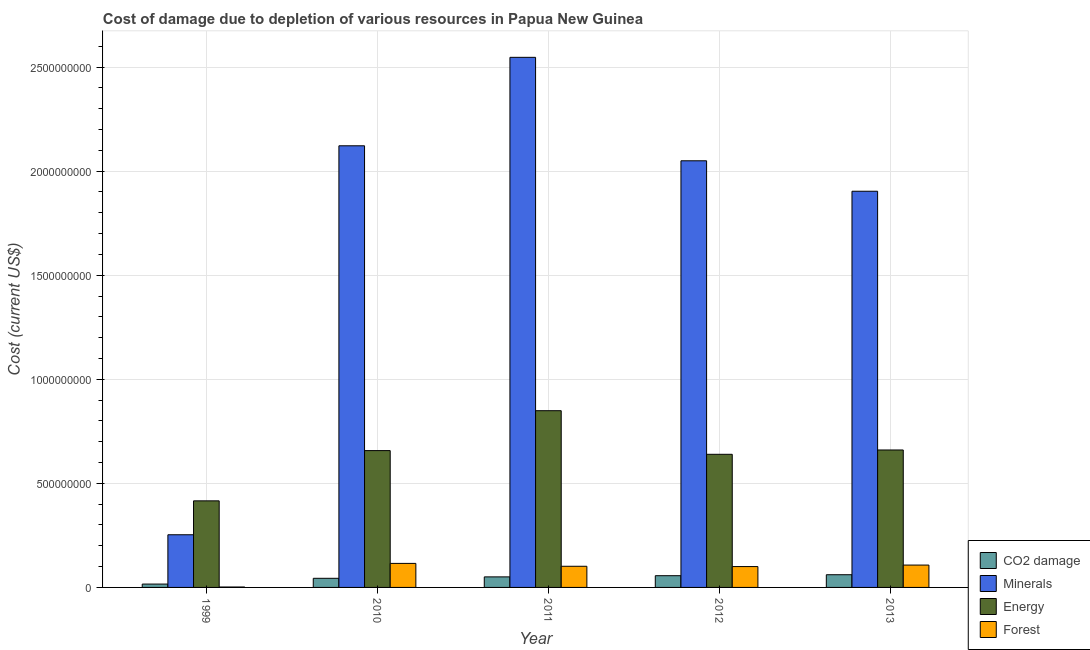How many different coloured bars are there?
Your answer should be very brief. 4. How many bars are there on the 1st tick from the left?
Provide a short and direct response. 4. In how many cases, is the number of bars for a given year not equal to the number of legend labels?
Provide a succinct answer. 0. What is the cost of damage due to depletion of energy in 2013?
Your response must be concise. 6.60e+08. Across all years, what is the maximum cost of damage due to depletion of energy?
Provide a succinct answer. 8.49e+08. Across all years, what is the minimum cost of damage due to depletion of forests?
Keep it short and to the point. 2.04e+06. In which year was the cost of damage due to depletion of minerals maximum?
Ensure brevity in your answer.  2011. What is the total cost of damage due to depletion of coal in the graph?
Provide a succinct answer. 2.28e+08. What is the difference between the cost of damage due to depletion of forests in 2010 and that in 2013?
Offer a very short reply. 8.03e+06. What is the difference between the cost of damage due to depletion of energy in 2010 and the cost of damage due to depletion of minerals in 1999?
Offer a terse response. 2.41e+08. What is the average cost of damage due to depletion of coal per year?
Make the answer very short. 4.56e+07. In how many years, is the cost of damage due to depletion of minerals greater than 2400000000 US$?
Your answer should be compact. 1. What is the ratio of the cost of damage due to depletion of minerals in 2010 to that in 2012?
Ensure brevity in your answer.  1.04. Is the difference between the cost of damage due to depletion of minerals in 1999 and 2010 greater than the difference between the cost of damage due to depletion of energy in 1999 and 2010?
Your answer should be compact. No. What is the difference between the highest and the second highest cost of damage due to depletion of minerals?
Provide a short and direct response. 4.25e+08. What is the difference between the highest and the lowest cost of damage due to depletion of forests?
Provide a short and direct response. 1.13e+08. In how many years, is the cost of damage due to depletion of minerals greater than the average cost of damage due to depletion of minerals taken over all years?
Your answer should be very brief. 4. Is it the case that in every year, the sum of the cost of damage due to depletion of energy and cost of damage due to depletion of coal is greater than the sum of cost of damage due to depletion of minerals and cost of damage due to depletion of forests?
Provide a succinct answer. No. What does the 4th bar from the left in 2011 represents?
Your answer should be compact. Forest. What does the 2nd bar from the right in 1999 represents?
Your answer should be very brief. Energy. Is it the case that in every year, the sum of the cost of damage due to depletion of coal and cost of damage due to depletion of minerals is greater than the cost of damage due to depletion of energy?
Keep it short and to the point. No. How many bars are there?
Your answer should be compact. 20. Are all the bars in the graph horizontal?
Your answer should be compact. No. How many years are there in the graph?
Your answer should be very brief. 5. Does the graph contain any zero values?
Ensure brevity in your answer.  No. Where does the legend appear in the graph?
Your response must be concise. Bottom right. What is the title of the graph?
Offer a terse response. Cost of damage due to depletion of various resources in Papua New Guinea . What is the label or title of the X-axis?
Provide a short and direct response. Year. What is the label or title of the Y-axis?
Make the answer very short. Cost (current US$). What is the Cost (current US$) in CO2 damage in 1999?
Ensure brevity in your answer.  1.61e+07. What is the Cost (current US$) of Minerals in 1999?
Make the answer very short. 2.53e+08. What is the Cost (current US$) in Energy in 1999?
Your answer should be very brief. 4.16e+08. What is the Cost (current US$) in Forest in 1999?
Keep it short and to the point. 2.04e+06. What is the Cost (current US$) of CO2 damage in 2010?
Your answer should be very brief. 4.38e+07. What is the Cost (current US$) in Minerals in 2010?
Make the answer very short. 2.12e+09. What is the Cost (current US$) in Energy in 2010?
Keep it short and to the point. 6.57e+08. What is the Cost (current US$) of Forest in 2010?
Provide a succinct answer. 1.15e+08. What is the Cost (current US$) of CO2 damage in 2011?
Offer a very short reply. 5.07e+07. What is the Cost (current US$) in Minerals in 2011?
Offer a terse response. 2.55e+09. What is the Cost (current US$) of Energy in 2011?
Keep it short and to the point. 8.49e+08. What is the Cost (current US$) of Forest in 2011?
Offer a very short reply. 1.02e+08. What is the Cost (current US$) in CO2 damage in 2012?
Keep it short and to the point. 5.64e+07. What is the Cost (current US$) of Minerals in 2012?
Keep it short and to the point. 2.05e+09. What is the Cost (current US$) of Energy in 2012?
Offer a very short reply. 6.40e+08. What is the Cost (current US$) of Forest in 2012?
Provide a short and direct response. 1.00e+08. What is the Cost (current US$) in CO2 damage in 2013?
Offer a very short reply. 6.10e+07. What is the Cost (current US$) of Minerals in 2013?
Offer a very short reply. 1.90e+09. What is the Cost (current US$) in Energy in 2013?
Your answer should be compact. 6.60e+08. What is the Cost (current US$) in Forest in 2013?
Keep it short and to the point. 1.07e+08. Across all years, what is the maximum Cost (current US$) of CO2 damage?
Give a very brief answer. 6.10e+07. Across all years, what is the maximum Cost (current US$) of Minerals?
Your answer should be very brief. 2.55e+09. Across all years, what is the maximum Cost (current US$) in Energy?
Keep it short and to the point. 8.49e+08. Across all years, what is the maximum Cost (current US$) of Forest?
Your response must be concise. 1.15e+08. Across all years, what is the minimum Cost (current US$) in CO2 damage?
Make the answer very short. 1.61e+07. Across all years, what is the minimum Cost (current US$) of Minerals?
Your answer should be compact. 2.53e+08. Across all years, what is the minimum Cost (current US$) in Energy?
Offer a very short reply. 4.16e+08. Across all years, what is the minimum Cost (current US$) in Forest?
Keep it short and to the point. 2.04e+06. What is the total Cost (current US$) in CO2 damage in the graph?
Your answer should be compact. 2.28e+08. What is the total Cost (current US$) in Minerals in the graph?
Give a very brief answer. 8.88e+09. What is the total Cost (current US$) in Energy in the graph?
Provide a succinct answer. 3.22e+09. What is the total Cost (current US$) in Forest in the graph?
Make the answer very short. 4.27e+08. What is the difference between the Cost (current US$) in CO2 damage in 1999 and that in 2010?
Make the answer very short. -2.77e+07. What is the difference between the Cost (current US$) of Minerals in 1999 and that in 2010?
Keep it short and to the point. -1.87e+09. What is the difference between the Cost (current US$) in Energy in 1999 and that in 2010?
Keep it short and to the point. -2.41e+08. What is the difference between the Cost (current US$) in Forest in 1999 and that in 2010?
Ensure brevity in your answer.  -1.13e+08. What is the difference between the Cost (current US$) in CO2 damage in 1999 and that in 2011?
Provide a short and direct response. -3.46e+07. What is the difference between the Cost (current US$) of Minerals in 1999 and that in 2011?
Your answer should be very brief. -2.29e+09. What is the difference between the Cost (current US$) of Energy in 1999 and that in 2011?
Give a very brief answer. -4.33e+08. What is the difference between the Cost (current US$) of Forest in 1999 and that in 2011?
Give a very brief answer. -9.96e+07. What is the difference between the Cost (current US$) in CO2 damage in 1999 and that in 2012?
Your response must be concise. -4.03e+07. What is the difference between the Cost (current US$) of Minerals in 1999 and that in 2012?
Make the answer very short. -1.80e+09. What is the difference between the Cost (current US$) in Energy in 1999 and that in 2012?
Ensure brevity in your answer.  -2.24e+08. What is the difference between the Cost (current US$) in Forest in 1999 and that in 2012?
Provide a short and direct response. -9.82e+07. What is the difference between the Cost (current US$) of CO2 damage in 1999 and that in 2013?
Keep it short and to the point. -4.49e+07. What is the difference between the Cost (current US$) of Minerals in 1999 and that in 2013?
Make the answer very short. -1.65e+09. What is the difference between the Cost (current US$) in Energy in 1999 and that in 2013?
Offer a very short reply. -2.44e+08. What is the difference between the Cost (current US$) of Forest in 1999 and that in 2013?
Offer a terse response. -1.05e+08. What is the difference between the Cost (current US$) of CO2 damage in 2010 and that in 2011?
Your response must be concise. -6.85e+06. What is the difference between the Cost (current US$) of Minerals in 2010 and that in 2011?
Keep it short and to the point. -4.25e+08. What is the difference between the Cost (current US$) in Energy in 2010 and that in 2011?
Ensure brevity in your answer.  -1.92e+08. What is the difference between the Cost (current US$) of Forest in 2010 and that in 2011?
Ensure brevity in your answer.  1.38e+07. What is the difference between the Cost (current US$) of CO2 damage in 2010 and that in 2012?
Offer a very short reply. -1.25e+07. What is the difference between the Cost (current US$) of Minerals in 2010 and that in 2012?
Offer a terse response. 7.20e+07. What is the difference between the Cost (current US$) of Energy in 2010 and that in 2012?
Ensure brevity in your answer.  1.78e+07. What is the difference between the Cost (current US$) in Forest in 2010 and that in 2012?
Offer a terse response. 1.52e+07. What is the difference between the Cost (current US$) of CO2 damage in 2010 and that in 2013?
Ensure brevity in your answer.  -1.72e+07. What is the difference between the Cost (current US$) of Minerals in 2010 and that in 2013?
Your answer should be compact. 2.18e+08. What is the difference between the Cost (current US$) in Energy in 2010 and that in 2013?
Make the answer very short. -2.94e+06. What is the difference between the Cost (current US$) in Forest in 2010 and that in 2013?
Provide a succinct answer. 8.03e+06. What is the difference between the Cost (current US$) of CO2 damage in 2011 and that in 2012?
Your response must be concise. -5.67e+06. What is the difference between the Cost (current US$) in Minerals in 2011 and that in 2012?
Give a very brief answer. 4.97e+08. What is the difference between the Cost (current US$) of Energy in 2011 and that in 2012?
Offer a terse response. 2.10e+08. What is the difference between the Cost (current US$) of Forest in 2011 and that in 2012?
Your answer should be very brief. 1.37e+06. What is the difference between the Cost (current US$) in CO2 damage in 2011 and that in 2013?
Provide a short and direct response. -1.03e+07. What is the difference between the Cost (current US$) in Minerals in 2011 and that in 2013?
Make the answer very short. 6.43e+08. What is the difference between the Cost (current US$) in Energy in 2011 and that in 2013?
Your response must be concise. 1.89e+08. What is the difference between the Cost (current US$) of Forest in 2011 and that in 2013?
Provide a short and direct response. -5.81e+06. What is the difference between the Cost (current US$) in CO2 damage in 2012 and that in 2013?
Your answer should be very brief. -4.64e+06. What is the difference between the Cost (current US$) in Minerals in 2012 and that in 2013?
Your response must be concise. 1.46e+08. What is the difference between the Cost (current US$) in Energy in 2012 and that in 2013?
Provide a short and direct response. -2.08e+07. What is the difference between the Cost (current US$) in Forest in 2012 and that in 2013?
Your answer should be compact. -7.18e+06. What is the difference between the Cost (current US$) of CO2 damage in 1999 and the Cost (current US$) of Minerals in 2010?
Give a very brief answer. -2.11e+09. What is the difference between the Cost (current US$) in CO2 damage in 1999 and the Cost (current US$) in Energy in 2010?
Offer a very short reply. -6.41e+08. What is the difference between the Cost (current US$) of CO2 damage in 1999 and the Cost (current US$) of Forest in 2010?
Offer a very short reply. -9.93e+07. What is the difference between the Cost (current US$) in Minerals in 1999 and the Cost (current US$) in Energy in 2010?
Your response must be concise. -4.04e+08. What is the difference between the Cost (current US$) in Minerals in 1999 and the Cost (current US$) in Forest in 2010?
Offer a terse response. 1.38e+08. What is the difference between the Cost (current US$) in Energy in 1999 and the Cost (current US$) in Forest in 2010?
Your response must be concise. 3.01e+08. What is the difference between the Cost (current US$) in CO2 damage in 1999 and the Cost (current US$) in Minerals in 2011?
Give a very brief answer. -2.53e+09. What is the difference between the Cost (current US$) of CO2 damage in 1999 and the Cost (current US$) of Energy in 2011?
Give a very brief answer. -8.33e+08. What is the difference between the Cost (current US$) in CO2 damage in 1999 and the Cost (current US$) in Forest in 2011?
Your answer should be very brief. -8.55e+07. What is the difference between the Cost (current US$) in Minerals in 1999 and the Cost (current US$) in Energy in 2011?
Provide a short and direct response. -5.96e+08. What is the difference between the Cost (current US$) in Minerals in 1999 and the Cost (current US$) in Forest in 2011?
Your answer should be very brief. 1.51e+08. What is the difference between the Cost (current US$) of Energy in 1999 and the Cost (current US$) of Forest in 2011?
Your response must be concise. 3.14e+08. What is the difference between the Cost (current US$) of CO2 damage in 1999 and the Cost (current US$) of Minerals in 2012?
Make the answer very short. -2.03e+09. What is the difference between the Cost (current US$) of CO2 damage in 1999 and the Cost (current US$) of Energy in 2012?
Offer a very short reply. -6.24e+08. What is the difference between the Cost (current US$) in CO2 damage in 1999 and the Cost (current US$) in Forest in 2012?
Offer a terse response. -8.41e+07. What is the difference between the Cost (current US$) of Minerals in 1999 and the Cost (current US$) of Energy in 2012?
Your answer should be very brief. -3.87e+08. What is the difference between the Cost (current US$) of Minerals in 1999 and the Cost (current US$) of Forest in 2012?
Your answer should be compact. 1.53e+08. What is the difference between the Cost (current US$) in Energy in 1999 and the Cost (current US$) in Forest in 2012?
Make the answer very short. 3.16e+08. What is the difference between the Cost (current US$) of CO2 damage in 1999 and the Cost (current US$) of Minerals in 2013?
Give a very brief answer. -1.89e+09. What is the difference between the Cost (current US$) in CO2 damage in 1999 and the Cost (current US$) in Energy in 2013?
Ensure brevity in your answer.  -6.44e+08. What is the difference between the Cost (current US$) of CO2 damage in 1999 and the Cost (current US$) of Forest in 2013?
Provide a succinct answer. -9.13e+07. What is the difference between the Cost (current US$) in Minerals in 1999 and the Cost (current US$) in Energy in 2013?
Your answer should be compact. -4.07e+08. What is the difference between the Cost (current US$) of Minerals in 1999 and the Cost (current US$) of Forest in 2013?
Keep it short and to the point. 1.46e+08. What is the difference between the Cost (current US$) of Energy in 1999 and the Cost (current US$) of Forest in 2013?
Keep it short and to the point. 3.09e+08. What is the difference between the Cost (current US$) in CO2 damage in 2010 and the Cost (current US$) in Minerals in 2011?
Your response must be concise. -2.50e+09. What is the difference between the Cost (current US$) in CO2 damage in 2010 and the Cost (current US$) in Energy in 2011?
Offer a terse response. -8.05e+08. What is the difference between the Cost (current US$) in CO2 damage in 2010 and the Cost (current US$) in Forest in 2011?
Your answer should be compact. -5.78e+07. What is the difference between the Cost (current US$) of Minerals in 2010 and the Cost (current US$) of Energy in 2011?
Keep it short and to the point. 1.27e+09. What is the difference between the Cost (current US$) of Minerals in 2010 and the Cost (current US$) of Forest in 2011?
Make the answer very short. 2.02e+09. What is the difference between the Cost (current US$) in Energy in 2010 and the Cost (current US$) in Forest in 2011?
Provide a short and direct response. 5.56e+08. What is the difference between the Cost (current US$) in CO2 damage in 2010 and the Cost (current US$) in Minerals in 2012?
Keep it short and to the point. -2.01e+09. What is the difference between the Cost (current US$) in CO2 damage in 2010 and the Cost (current US$) in Energy in 2012?
Make the answer very short. -5.96e+08. What is the difference between the Cost (current US$) in CO2 damage in 2010 and the Cost (current US$) in Forest in 2012?
Offer a very short reply. -5.64e+07. What is the difference between the Cost (current US$) of Minerals in 2010 and the Cost (current US$) of Energy in 2012?
Offer a very short reply. 1.48e+09. What is the difference between the Cost (current US$) in Minerals in 2010 and the Cost (current US$) in Forest in 2012?
Offer a terse response. 2.02e+09. What is the difference between the Cost (current US$) of Energy in 2010 and the Cost (current US$) of Forest in 2012?
Offer a terse response. 5.57e+08. What is the difference between the Cost (current US$) of CO2 damage in 2010 and the Cost (current US$) of Minerals in 2013?
Give a very brief answer. -1.86e+09. What is the difference between the Cost (current US$) of CO2 damage in 2010 and the Cost (current US$) of Energy in 2013?
Make the answer very short. -6.17e+08. What is the difference between the Cost (current US$) of CO2 damage in 2010 and the Cost (current US$) of Forest in 2013?
Your answer should be very brief. -6.36e+07. What is the difference between the Cost (current US$) in Minerals in 2010 and the Cost (current US$) in Energy in 2013?
Give a very brief answer. 1.46e+09. What is the difference between the Cost (current US$) of Minerals in 2010 and the Cost (current US$) of Forest in 2013?
Give a very brief answer. 2.01e+09. What is the difference between the Cost (current US$) in Energy in 2010 and the Cost (current US$) in Forest in 2013?
Provide a succinct answer. 5.50e+08. What is the difference between the Cost (current US$) in CO2 damage in 2011 and the Cost (current US$) in Minerals in 2012?
Your answer should be very brief. -2.00e+09. What is the difference between the Cost (current US$) in CO2 damage in 2011 and the Cost (current US$) in Energy in 2012?
Offer a terse response. -5.89e+08. What is the difference between the Cost (current US$) of CO2 damage in 2011 and the Cost (current US$) of Forest in 2012?
Offer a very short reply. -4.95e+07. What is the difference between the Cost (current US$) in Minerals in 2011 and the Cost (current US$) in Energy in 2012?
Provide a short and direct response. 1.91e+09. What is the difference between the Cost (current US$) in Minerals in 2011 and the Cost (current US$) in Forest in 2012?
Your response must be concise. 2.45e+09. What is the difference between the Cost (current US$) in Energy in 2011 and the Cost (current US$) in Forest in 2012?
Offer a terse response. 7.49e+08. What is the difference between the Cost (current US$) in CO2 damage in 2011 and the Cost (current US$) in Minerals in 2013?
Make the answer very short. -1.85e+09. What is the difference between the Cost (current US$) of CO2 damage in 2011 and the Cost (current US$) of Energy in 2013?
Provide a short and direct response. -6.10e+08. What is the difference between the Cost (current US$) of CO2 damage in 2011 and the Cost (current US$) of Forest in 2013?
Your response must be concise. -5.67e+07. What is the difference between the Cost (current US$) in Minerals in 2011 and the Cost (current US$) in Energy in 2013?
Your answer should be very brief. 1.89e+09. What is the difference between the Cost (current US$) of Minerals in 2011 and the Cost (current US$) of Forest in 2013?
Your response must be concise. 2.44e+09. What is the difference between the Cost (current US$) of Energy in 2011 and the Cost (current US$) of Forest in 2013?
Offer a very short reply. 7.42e+08. What is the difference between the Cost (current US$) in CO2 damage in 2012 and the Cost (current US$) in Minerals in 2013?
Your answer should be very brief. -1.85e+09. What is the difference between the Cost (current US$) in CO2 damage in 2012 and the Cost (current US$) in Energy in 2013?
Offer a very short reply. -6.04e+08. What is the difference between the Cost (current US$) in CO2 damage in 2012 and the Cost (current US$) in Forest in 2013?
Offer a very short reply. -5.11e+07. What is the difference between the Cost (current US$) in Minerals in 2012 and the Cost (current US$) in Energy in 2013?
Your response must be concise. 1.39e+09. What is the difference between the Cost (current US$) of Minerals in 2012 and the Cost (current US$) of Forest in 2013?
Make the answer very short. 1.94e+09. What is the difference between the Cost (current US$) of Energy in 2012 and the Cost (current US$) of Forest in 2013?
Your answer should be compact. 5.32e+08. What is the average Cost (current US$) in CO2 damage per year?
Offer a very short reply. 4.56e+07. What is the average Cost (current US$) in Minerals per year?
Your response must be concise. 1.78e+09. What is the average Cost (current US$) in Energy per year?
Your answer should be very brief. 6.45e+08. What is the average Cost (current US$) of Forest per year?
Give a very brief answer. 8.53e+07. In the year 1999, what is the difference between the Cost (current US$) of CO2 damage and Cost (current US$) of Minerals?
Offer a very short reply. -2.37e+08. In the year 1999, what is the difference between the Cost (current US$) in CO2 damage and Cost (current US$) in Energy?
Your answer should be very brief. -4.00e+08. In the year 1999, what is the difference between the Cost (current US$) of CO2 damage and Cost (current US$) of Forest?
Your answer should be very brief. 1.41e+07. In the year 1999, what is the difference between the Cost (current US$) of Minerals and Cost (current US$) of Energy?
Give a very brief answer. -1.63e+08. In the year 1999, what is the difference between the Cost (current US$) in Minerals and Cost (current US$) in Forest?
Your response must be concise. 2.51e+08. In the year 1999, what is the difference between the Cost (current US$) of Energy and Cost (current US$) of Forest?
Keep it short and to the point. 4.14e+08. In the year 2010, what is the difference between the Cost (current US$) of CO2 damage and Cost (current US$) of Minerals?
Provide a succinct answer. -2.08e+09. In the year 2010, what is the difference between the Cost (current US$) in CO2 damage and Cost (current US$) in Energy?
Your response must be concise. -6.14e+08. In the year 2010, what is the difference between the Cost (current US$) of CO2 damage and Cost (current US$) of Forest?
Make the answer very short. -7.16e+07. In the year 2010, what is the difference between the Cost (current US$) of Minerals and Cost (current US$) of Energy?
Provide a succinct answer. 1.46e+09. In the year 2010, what is the difference between the Cost (current US$) in Minerals and Cost (current US$) in Forest?
Give a very brief answer. 2.01e+09. In the year 2010, what is the difference between the Cost (current US$) of Energy and Cost (current US$) of Forest?
Provide a succinct answer. 5.42e+08. In the year 2011, what is the difference between the Cost (current US$) in CO2 damage and Cost (current US$) in Minerals?
Your answer should be very brief. -2.50e+09. In the year 2011, what is the difference between the Cost (current US$) of CO2 damage and Cost (current US$) of Energy?
Offer a very short reply. -7.98e+08. In the year 2011, what is the difference between the Cost (current US$) in CO2 damage and Cost (current US$) in Forest?
Your answer should be compact. -5.09e+07. In the year 2011, what is the difference between the Cost (current US$) in Minerals and Cost (current US$) in Energy?
Ensure brevity in your answer.  1.70e+09. In the year 2011, what is the difference between the Cost (current US$) in Minerals and Cost (current US$) in Forest?
Keep it short and to the point. 2.45e+09. In the year 2011, what is the difference between the Cost (current US$) of Energy and Cost (current US$) of Forest?
Provide a short and direct response. 7.48e+08. In the year 2012, what is the difference between the Cost (current US$) of CO2 damage and Cost (current US$) of Minerals?
Provide a succinct answer. -1.99e+09. In the year 2012, what is the difference between the Cost (current US$) of CO2 damage and Cost (current US$) of Energy?
Make the answer very short. -5.83e+08. In the year 2012, what is the difference between the Cost (current US$) of CO2 damage and Cost (current US$) of Forest?
Your answer should be very brief. -4.39e+07. In the year 2012, what is the difference between the Cost (current US$) in Minerals and Cost (current US$) in Energy?
Your response must be concise. 1.41e+09. In the year 2012, what is the difference between the Cost (current US$) in Minerals and Cost (current US$) in Forest?
Give a very brief answer. 1.95e+09. In the year 2012, what is the difference between the Cost (current US$) of Energy and Cost (current US$) of Forest?
Give a very brief answer. 5.39e+08. In the year 2013, what is the difference between the Cost (current US$) in CO2 damage and Cost (current US$) in Minerals?
Keep it short and to the point. -1.84e+09. In the year 2013, what is the difference between the Cost (current US$) of CO2 damage and Cost (current US$) of Energy?
Your answer should be very brief. -5.99e+08. In the year 2013, what is the difference between the Cost (current US$) in CO2 damage and Cost (current US$) in Forest?
Your answer should be compact. -4.64e+07. In the year 2013, what is the difference between the Cost (current US$) of Minerals and Cost (current US$) of Energy?
Your response must be concise. 1.24e+09. In the year 2013, what is the difference between the Cost (current US$) of Minerals and Cost (current US$) of Forest?
Offer a terse response. 1.80e+09. In the year 2013, what is the difference between the Cost (current US$) of Energy and Cost (current US$) of Forest?
Keep it short and to the point. 5.53e+08. What is the ratio of the Cost (current US$) in CO2 damage in 1999 to that in 2010?
Offer a terse response. 0.37. What is the ratio of the Cost (current US$) in Minerals in 1999 to that in 2010?
Ensure brevity in your answer.  0.12. What is the ratio of the Cost (current US$) of Energy in 1999 to that in 2010?
Your answer should be compact. 0.63. What is the ratio of the Cost (current US$) in Forest in 1999 to that in 2010?
Keep it short and to the point. 0.02. What is the ratio of the Cost (current US$) of CO2 damage in 1999 to that in 2011?
Your response must be concise. 0.32. What is the ratio of the Cost (current US$) of Minerals in 1999 to that in 2011?
Offer a very short reply. 0.1. What is the ratio of the Cost (current US$) in Energy in 1999 to that in 2011?
Provide a succinct answer. 0.49. What is the ratio of the Cost (current US$) of Forest in 1999 to that in 2011?
Make the answer very short. 0.02. What is the ratio of the Cost (current US$) of CO2 damage in 1999 to that in 2012?
Provide a short and direct response. 0.29. What is the ratio of the Cost (current US$) of Minerals in 1999 to that in 2012?
Make the answer very short. 0.12. What is the ratio of the Cost (current US$) in Energy in 1999 to that in 2012?
Provide a succinct answer. 0.65. What is the ratio of the Cost (current US$) in Forest in 1999 to that in 2012?
Offer a terse response. 0.02. What is the ratio of the Cost (current US$) of CO2 damage in 1999 to that in 2013?
Provide a succinct answer. 0.26. What is the ratio of the Cost (current US$) of Minerals in 1999 to that in 2013?
Give a very brief answer. 0.13. What is the ratio of the Cost (current US$) in Energy in 1999 to that in 2013?
Make the answer very short. 0.63. What is the ratio of the Cost (current US$) of Forest in 1999 to that in 2013?
Provide a short and direct response. 0.02. What is the ratio of the Cost (current US$) in CO2 damage in 2010 to that in 2011?
Provide a succinct answer. 0.86. What is the ratio of the Cost (current US$) of Minerals in 2010 to that in 2011?
Provide a succinct answer. 0.83. What is the ratio of the Cost (current US$) in Energy in 2010 to that in 2011?
Your response must be concise. 0.77. What is the ratio of the Cost (current US$) in Forest in 2010 to that in 2011?
Provide a succinct answer. 1.14. What is the ratio of the Cost (current US$) in CO2 damage in 2010 to that in 2012?
Provide a succinct answer. 0.78. What is the ratio of the Cost (current US$) of Minerals in 2010 to that in 2012?
Your answer should be compact. 1.04. What is the ratio of the Cost (current US$) of Energy in 2010 to that in 2012?
Ensure brevity in your answer.  1.03. What is the ratio of the Cost (current US$) of Forest in 2010 to that in 2012?
Your answer should be compact. 1.15. What is the ratio of the Cost (current US$) in CO2 damage in 2010 to that in 2013?
Offer a terse response. 0.72. What is the ratio of the Cost (current US$) in Minerals in 2010 to that in 2013?
Your answer should be compact. 1.11. What is the ratio of the Cost (current US$) of Energy in 2010 to that in 2013?
Make the answer very short. 1. What is the ratio of the Cost (current US$) in Forest in 2010 to that in 2013?
Provide a short and direct response. 1.07. What is the ratio of the Cost (current US$) in CO2 damage in 2011 to that in 2012?
Make the answer very short. 0.9. What is the ratio of the Cost (current US$) in Minerals in 2011 to that in 2012?
Ensure brevity in your answer.  1.24. What is the ratio of the Cost (current US$) of Energy in 2011 to that in 2012?
Offer a very short reply. 1.33. What is the ratio of the Cost (current US$) in Forest in 2011 to that in 2012?
Ensure brevity in your answer.  1.01. What is the ratio of the Cost (current US$) of CO2 damage in 2011 to that in 2013?
Keep it short and to the point. 0.83. What is the ratio of the Cost (current US$) of Minerals in 2011 to that in 2013?
Provide a succinct answer. 1.34. What is the ratio of the Cost (current US$) in Energy in 2011 to that in 2013?
Provide a short and direct response. 1.29. What is the ratio of the Cost (current US$) in Forest in 2011 to that in 2013?
Provide a short and direct response. 0.95. What is the ratio of the Cost (current US$) of CO2 damage in 2012 to that in 2013?
Make the answer very short. 0.92. What is the ratio of the Cost (current US$) in Energy in 2012 to that in 2013?
Offer a terse response. 0.97. What is the ratio of the Cost (current US$) in Forest in 2012 to that in 2013?
Your response must be concise. 0.93. What is the difference between the highest and the second highest Cost (current US$) in CO2 damage?
Keep it short and to the point. 4.64e+06. What is the difference between the highest and the second highest Cost (current US$) of Minerals?
Offer a very short reply. 4.25e+08. What is the difference between the highest and the second highest Cost (current US$) of Energy?
Your answer should be compact. 1.89e+08. What is the difference between the highest and the second highest Cost (current US$) of Forest?
Provide a short and direct response. 8.03e+06. What is the difference between the highest and the lowest Cost (current US$) of CO2 damage?
Provide a short and direct response. 4.49e+07. What is the difference between the highest and the lowest Cost (current US$) of Minerals?
Provide a short and direct response. 2.29e+09. What is the difference between the highest and the lowest Cost (current US$) of Energy?
Offer a terse response. 4.33e+08. What is the difference between the highest and the lowest Cost (current US$) of Forest?
Provide a succinct answer. 1.13e+08. 